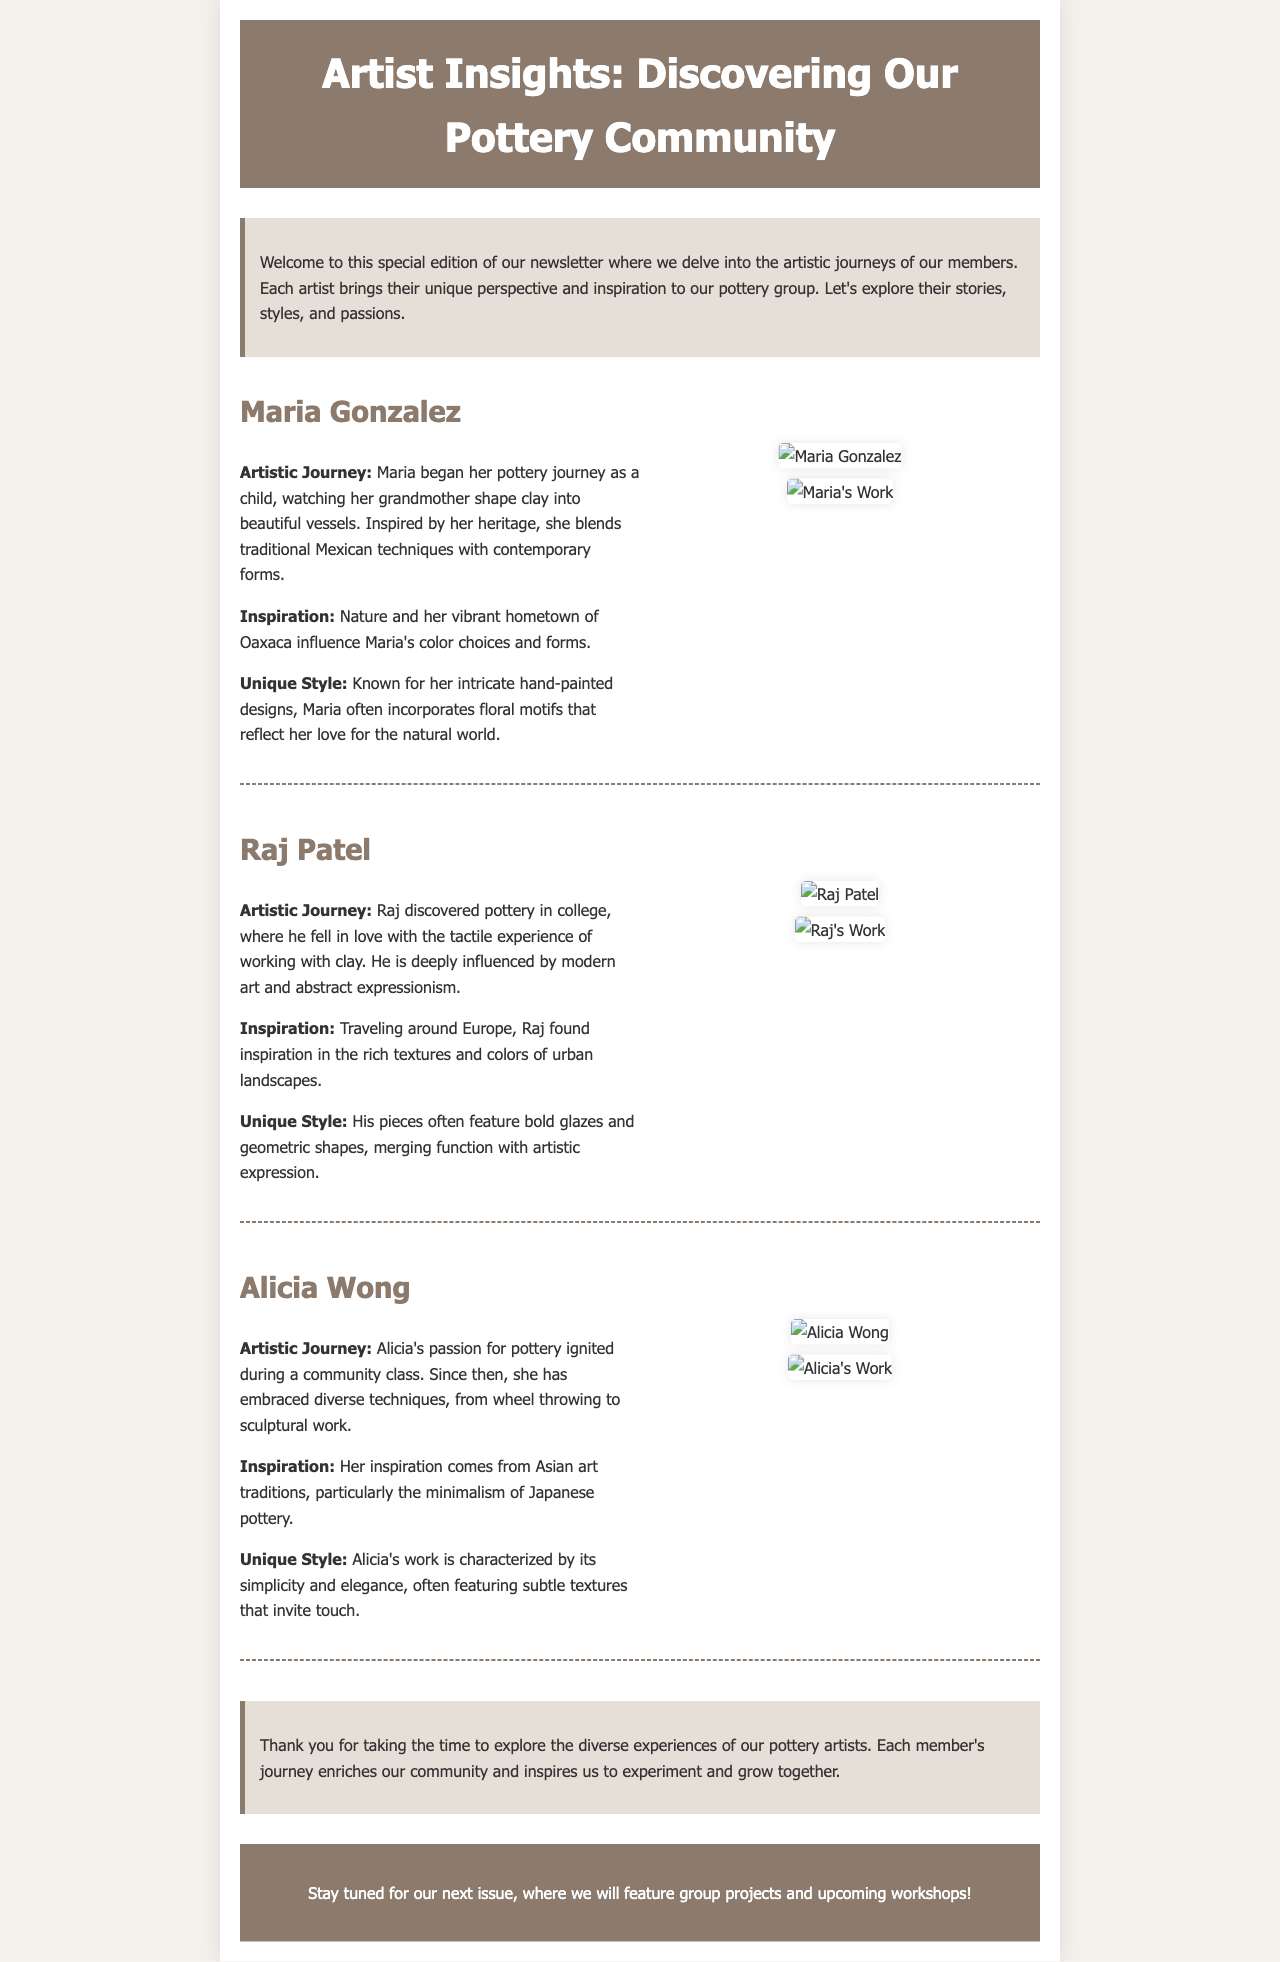what is the title of the newsletter? The title is prominently displayed in the header of the document.
Answer: Artist Insights: Discovering Our Pottery Community who is featured in the first artist interview? The first artist's name is listed at the beginning of their section.
Answer: Maria Gonzalez which artist was inspired by urban landscapes? The document contains information about each artist's inspirations.
Answer: Raj Patel what technique did Alicia Wong embrace in her artistic journey? The document mentions various techniques that each artist has explored.
Answer: Sculptural work how many artists are interviewed in this newsletter? The total number of artist sections indicates the number of interviews.
Answer: Three which color is used for the header background? The background color of the header section is specified in the style.
Answer: #8c7b6d what is the main inspiration for Maria Gonzalez's color choices? The document provides insights into each artist's sources of inspiration.
Answer: Nature what kind of motifs does Maria Gonzalez often use in her work? The section describing Maria's unique style provides specific details about her design choices.
Answer: Floral motifs what upcoming content is mentioned at the end of the newsletter? The final call-to-action section hints at future features in the newsletter.
Answer: Group projects and upcoming workshops! 